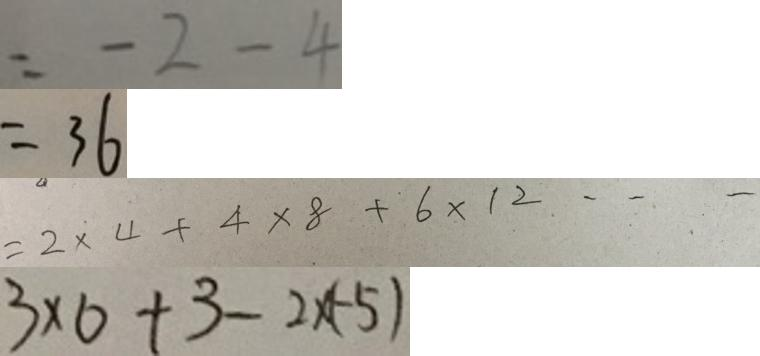Convert formula to latex. <formula><loc_0><loc_0><loc_500><loc_500>= - 2 - 4 
 = 3 6 
 = 2 \times 4 + 4 \times 8 + 6 \times 1 2 \cdots 
 3 \times 0 + 3 - 2 \times ( - 5 )</formula> 